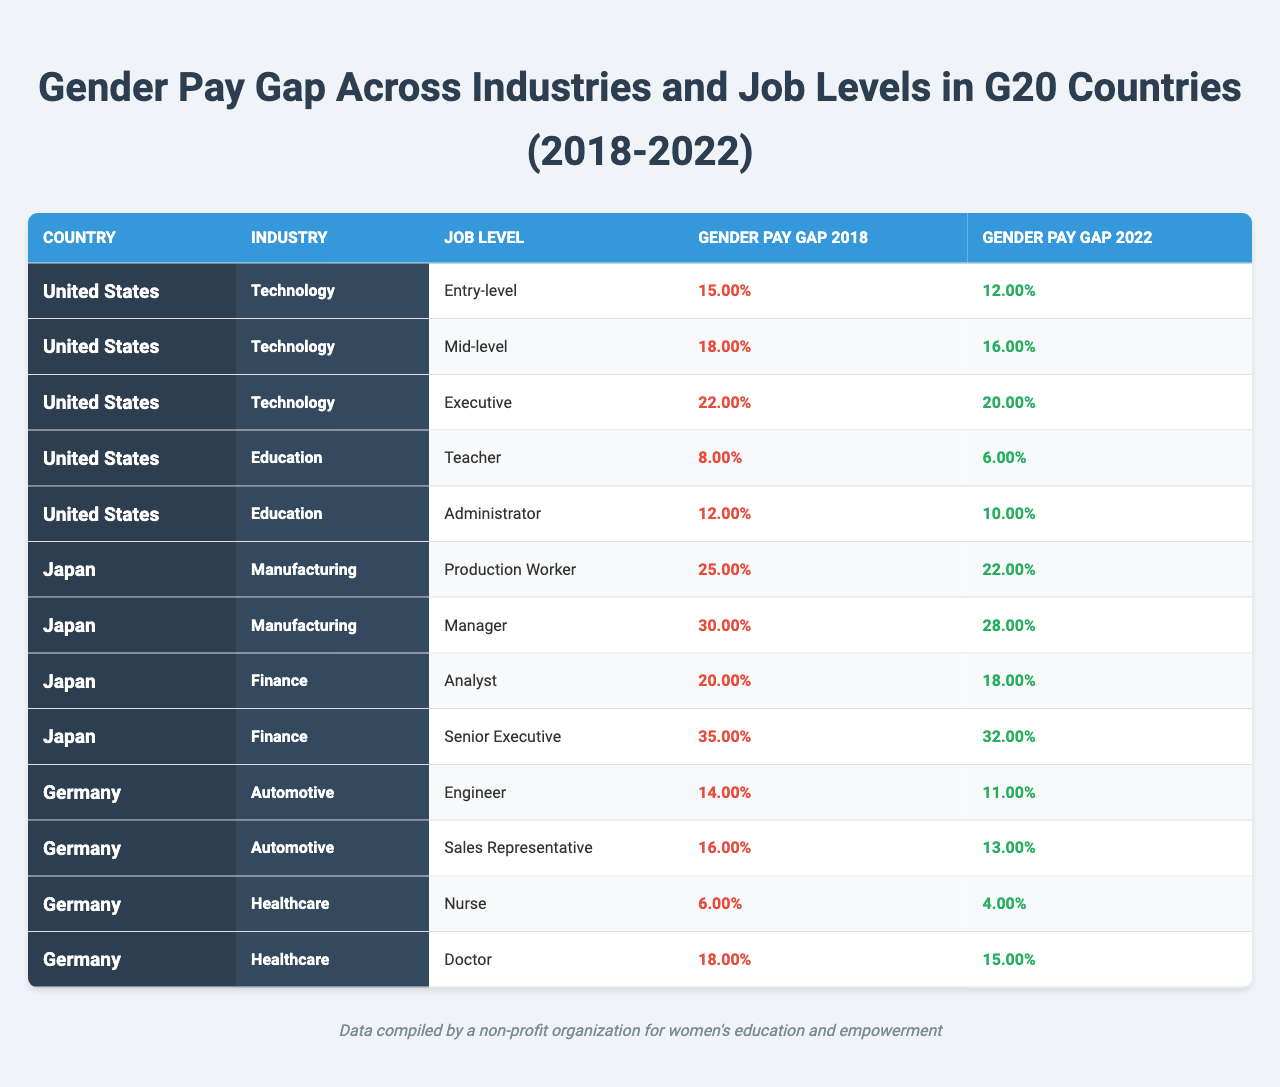What was the gender pay gap for entry-level positions in the technology industry in the United States in 2018? The table shows the gender pay gap for entry-level positions in the technology industry in the United States as 15% in 2018.
Answer: 15% Which job level in education experienced the largest reduction in the gender pay gap from 2018 to 2022 in the United States? For education, the teacher position had a gap of 8% in 2018 and 6% in 2022 (2% reduction), and the administrator had a gap of 12% in 2018 and 10% in 2022 (2% reduction), thus both had the same reduction.
Answer: Teacher and Administrator What is the gender pay gap for nurses in Germany in 2022? According to the table, the gender pay gap for nurses in Germany in 2022 is 4%.
Answer: 4% Which industry has the highest gender pay gap for executives in the G20 countries? The executive gender pay gap for Japan's finance industry is 32%, which is higher than 20% in the United States and 15% in Germany. Hence, finance in Japan has the highest executive pay gap.
Answer: Finance in Japan What was the overall trend in gender pay gaps from 2018 to 2022 for the automobile industry in Germany? In the automobile industry, the gender pay gap decreased from 14% in 2018 to 11% in 2022 for engineers, and from 16% in 2018 to 13% in 2022 for sales representatives. Hence, there is a consistent decrease.
Answer: Decrease Did any job level in the manufacturing industry of Japan show improvement in gender pay gap between 2018 and 2022? Yes, both job levels in manufacturing in Japan (Production Worker from 25% to 22% and Manager from 30% to 28%) show improvements, indicating a decrease in gender pay gap for both levels.
Answer: Yes What is the average gender pay gap for mid-level jobs across the G20 countries in 2022? In the United States, the mid-level gap is 16%, Japan has 18%, and Germany has no mid-level data. The average can be calculated as (16% + 18%)/2 = 17%.
Answer: 17% Is the gender pay gap for male executives higher than for female executives in the finance industry of Japan in 2022? The gender pay gap for senior executives in Japan's finance is noted as 32%, which indicates male compensation is higher than female, confirming the gap.
Answer: Yes Which industry had the smallest gender pay gap for doctors in 2022? The healthcare industry in Germany shows a gender pay gap of 15% for doctors, whereas other mentioned industries in the other countries have higher gaps, indicating it is the smallest.
Answer: Healthcare in Germany How much has the gender pay gap for Production Workers in Japan changed from 2018 to 2022? The pay gap changed from 25% in 2018 to 22% in 2022, a decrease of 3%.
Answer: Decreased by 3% 